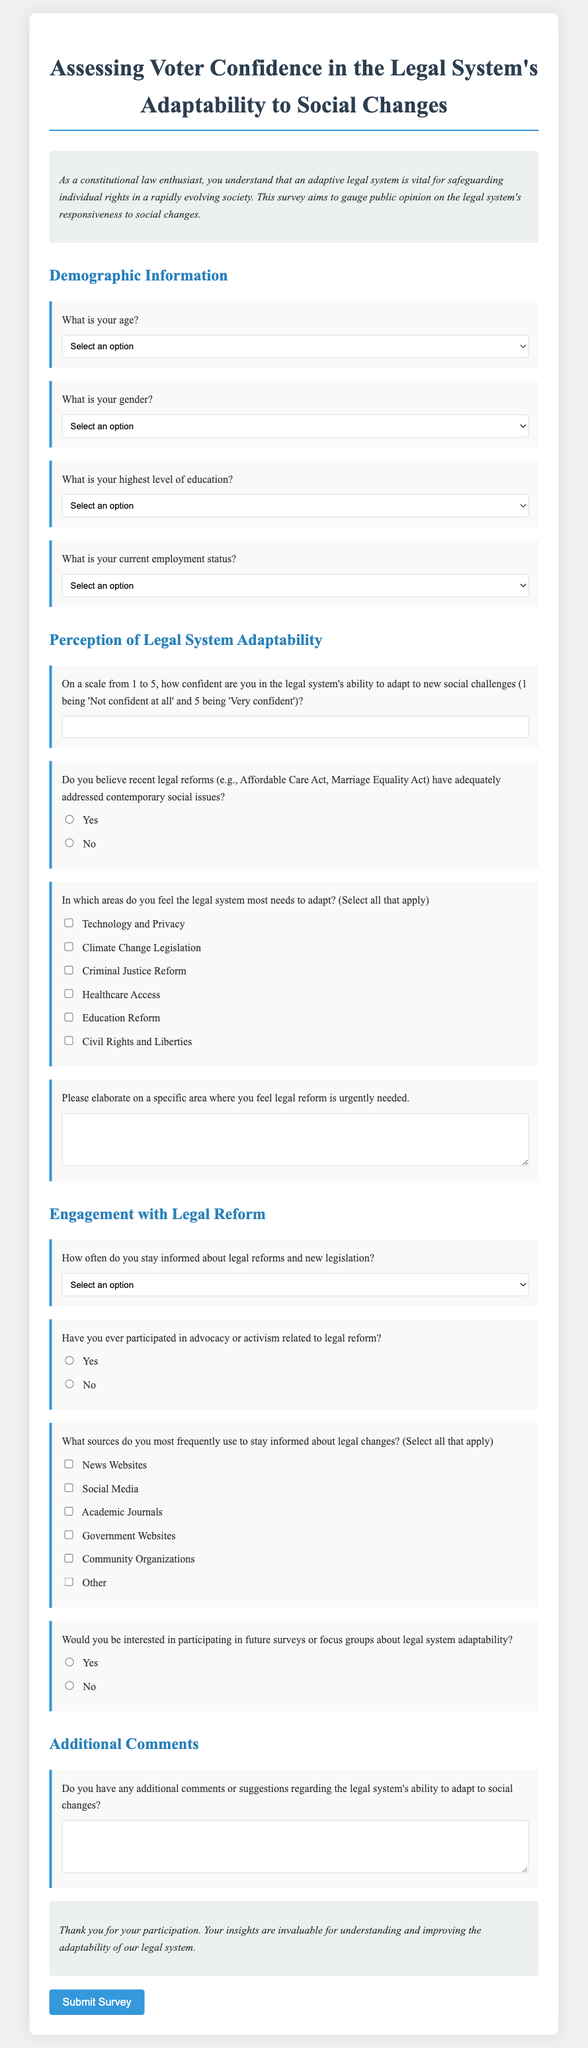What is the title of the survey? The title is prominently displayed at the top of the document, indicating the focus of the survey.
Answer: Assessing Voter Confidence in the Legal System's Adaptability to Social Changes How many demographic questions are included in the survey? The survey lists a section for demographic information with a total of four questions.
Answer: 4 What is the minimum rating for confidence in the legal system's adaptability? The document specifies the scale for rating confidence, stating the lowest possible score.
Answer: 1 Which area is NOT listed as needing legal system adaptation? The document lists various areas for adaptation but does not mention an area related to "Economic Policy."
Answer: Economic Policy What frequency option is given for staying informed about legal reforms? The survey includes a selection of frequency options to gauge how often participants engage with legal information.
Answer: Daily 